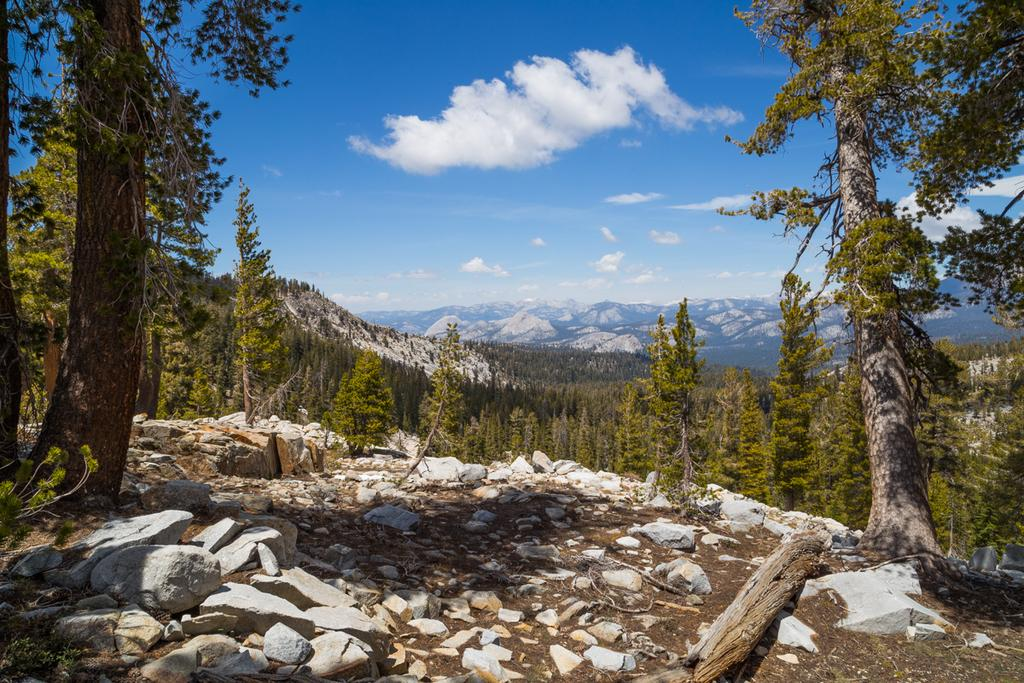What type of natural feature can be seen on the path in the image? There are rocks on the path in the image. What is located behind the rocks on the path? There are trees behind the rocks. What type of landscape can be seen in the distance in the image? There are hills visible in the image. What is visible above the landscape in the image? The sky is visible in the image. Can you see any cords attached to the trees in the image? There are no cords visible in the image; only rocks, trees, hills, and the sky are present. Is there a spy observing the scene from a hidden location in the image? There is no indication of a spy or any hidden observer in the image. 